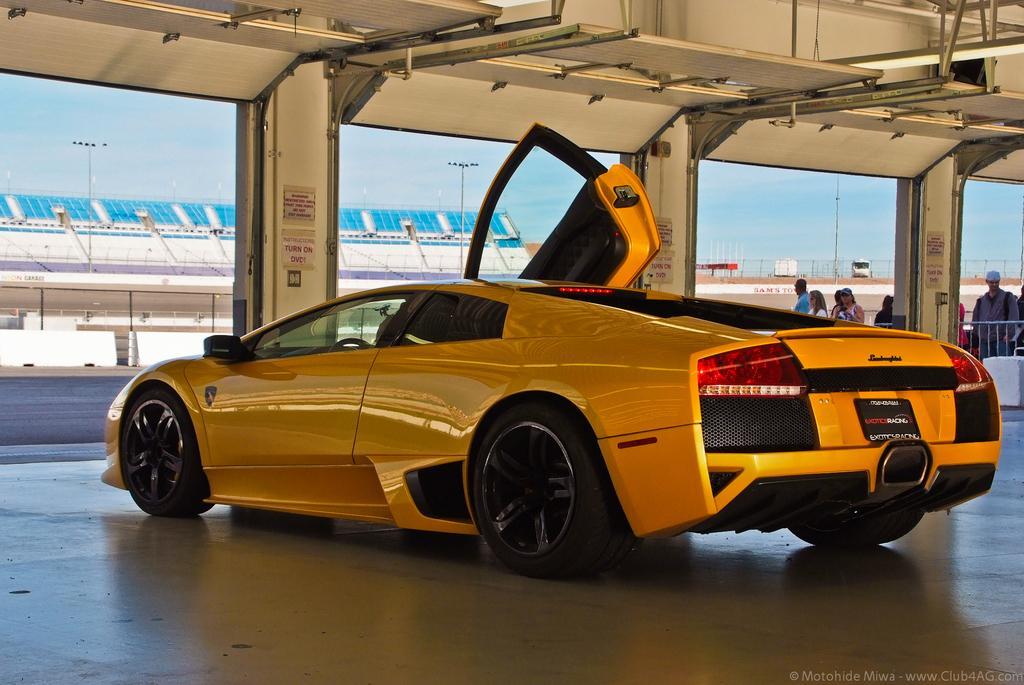Please provide a concise description of this image. In this image a car is on the floor. There are few pillars attached to the wall. Few persons are behind the fence. Left side there is a building. There are few street lights. Background there is sky. Right bottom there is a suitcase on the floor. 